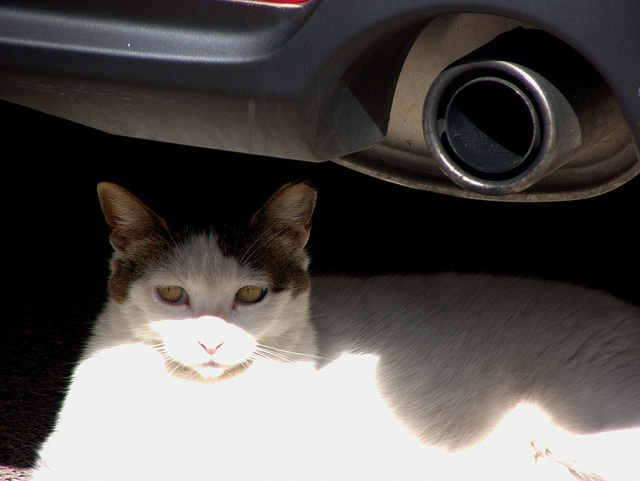Describe the objects in this image and their specific colors. I can see cat in black, white, gray, and darkgray tones and car in black and gray tones in this image. 